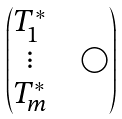<formula> <loc_0><loc_0><loc_500><loc_500>\begin{pmatrix} T _ { 1 } ^ { \ast } & & \\ \vdots & & \bigcirc \\ T _ { m } ^ { \ast } & & \end{pmatrix}</formula> 